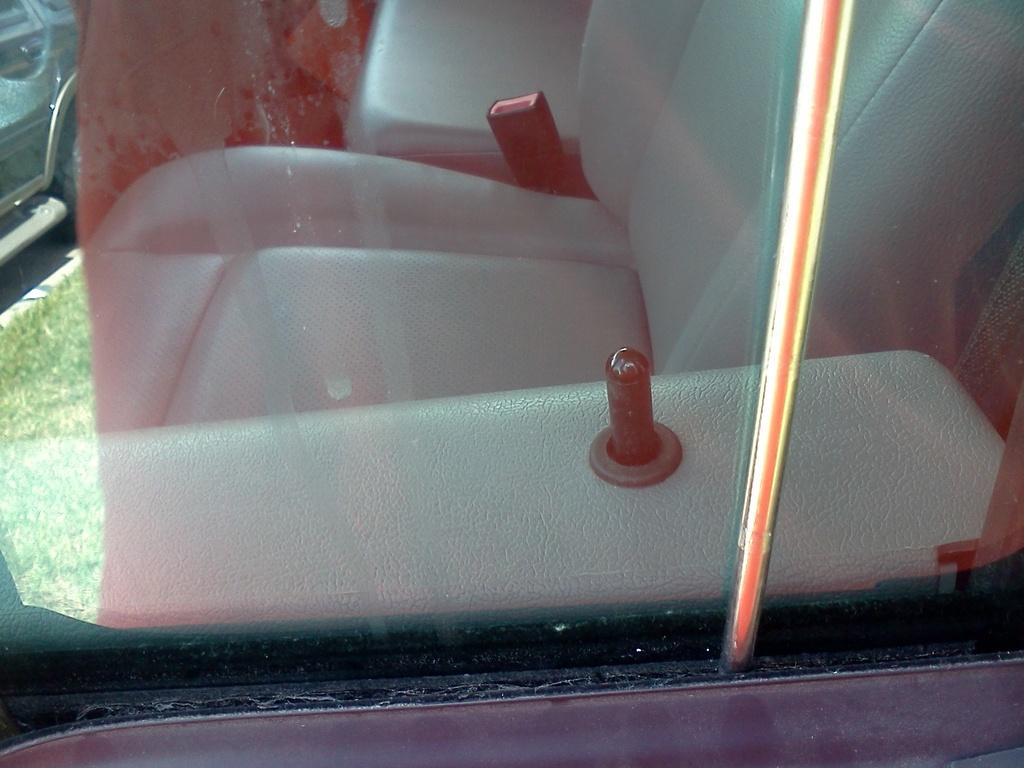What material is the transparent object in the image made of? There is transparent glass in the image. What can be seen through the glass? Seats are visible through the glass. How many main objects or subjects are present in the image? There are two things in the image. What is the reflection of in the image? The reflection of green grass is visible in the image. What type of chalk is being used to draw on the elbow in the image? There is no chalk or elbow present in the image. On which side of the glass are the seats located in the image? The image does not specify a particular side for the seats; they are simply visible through the transparent glass. 